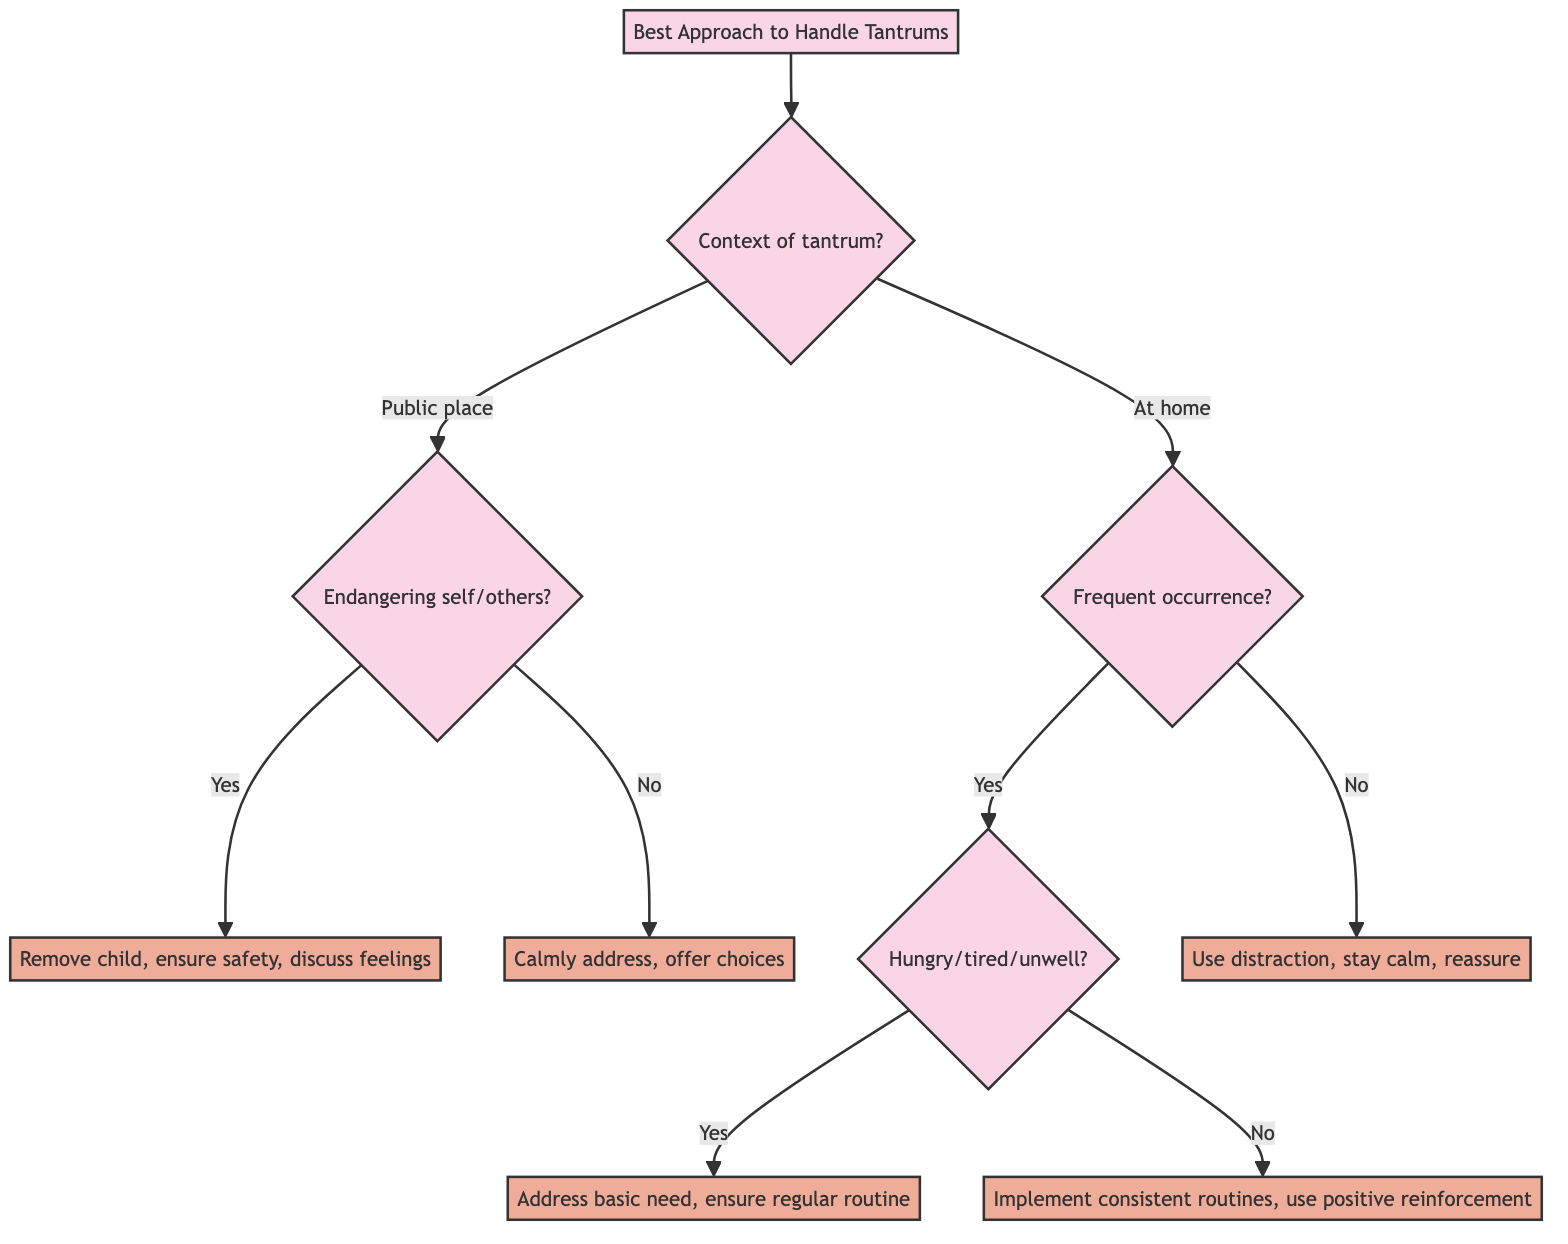What is the first question asked in the diagram? The first question in the diagram is about the context of the tantrum. It initiates the decision-making process that leads to various discipline strategies.
Answer: What is the context of the tantrum? What are the two contexts of tantrums presented? The two contexts presented in the diagram are "In a public place" and "At home." Each context leads to different subsequent questions and strategies.
Answer: In a public place, At home If the tantrum is in a public place and the child is not endangering themselves, what is the strategy? The strategy when the tantrum occurs in a public place and the child is not endangering themselves is to calmly but firmly address the behavior and offer choices to help the child regain control.
Answer: Calmly address, offer choices What should be checked if the tantrum at home is a frequent occurrence? If the tantrum at home is a frequent occurrence, the next question to check is whether the child could be hungry, tired, or feeling unwell. This helps identify underlying needs that may be contributing to the behavior.
Answer: Hungry, tired, or feeling unwell? What strategy is advised for frequent tantrums caused by unmet basic needs? The advised strategy for frequent tantrums caused by unmet basic needs is to address the basic need first by ensuring regular mealtimes, naps, and a healthy environment. This approach aims to alleviate the underlying issues that may be triggering the tantrums.
Answer: Address basic need, ensure regular routine How does the strategy differ for infrequent tantrums versus frequent tantrums? For infrequent tantrums, the strategy is to use distraction techniques to divert attention and maintain calmness while offering reassurance. In contrast, for frequent tantrums, it becomes essential to investigate deeper issues like unmet basic needs and implement consistent routines with positive reinforcement.
Answer: Use distraction for infrequent; investigate needs and routines for frequent 